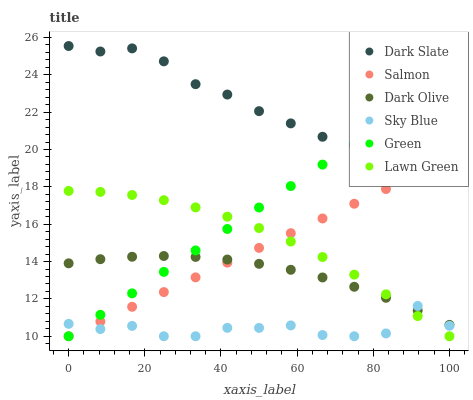Does Sky Blue have the minimum area under the curve?
Answer yes or no. Yes. Does Dark Slate have the maximum area under the curve?
Answer yes or no. Yes. Does Dark Olive have the minimum area under the curve?
Answer yes or no. No. Does Dark Olive have the maximum area under the curve?
Answer yes or no. No. Is Salmon the smoothest?
Answer yes or no. Yes. Is Sky Blue the roughest?
Answer yes or no. Yes. Is Dark Olive the smoothest?
Answer yes or no. No. Is Dark Olive the roughest?
Answer yes or no. No. Does Lawn Green have the lowest value?
Answer yes or no. Yes. Does Dark Olive have the lowest value?
Answer yes or no. No. Does Dark Slate have the highest value?
Answer yes or no. Yes. Does Dark Olive have the highest value?
Answer yes or no. No. Is Sky Blue less than Dark Slate?
Answer yes or no. Yes. Is Dark Slate greater than Lawn Green?
Answer yes or no. Yes. Does Lawn Green intersect Green?
Answer yes or no. Yes. Is Lawn Green less than Green?
Answer yes or no. No. Is Lawn Green greater than Green?
Answer yes or no. No. Does Sky Blue intersect Dark Slate?
Answer yes or no. No. 